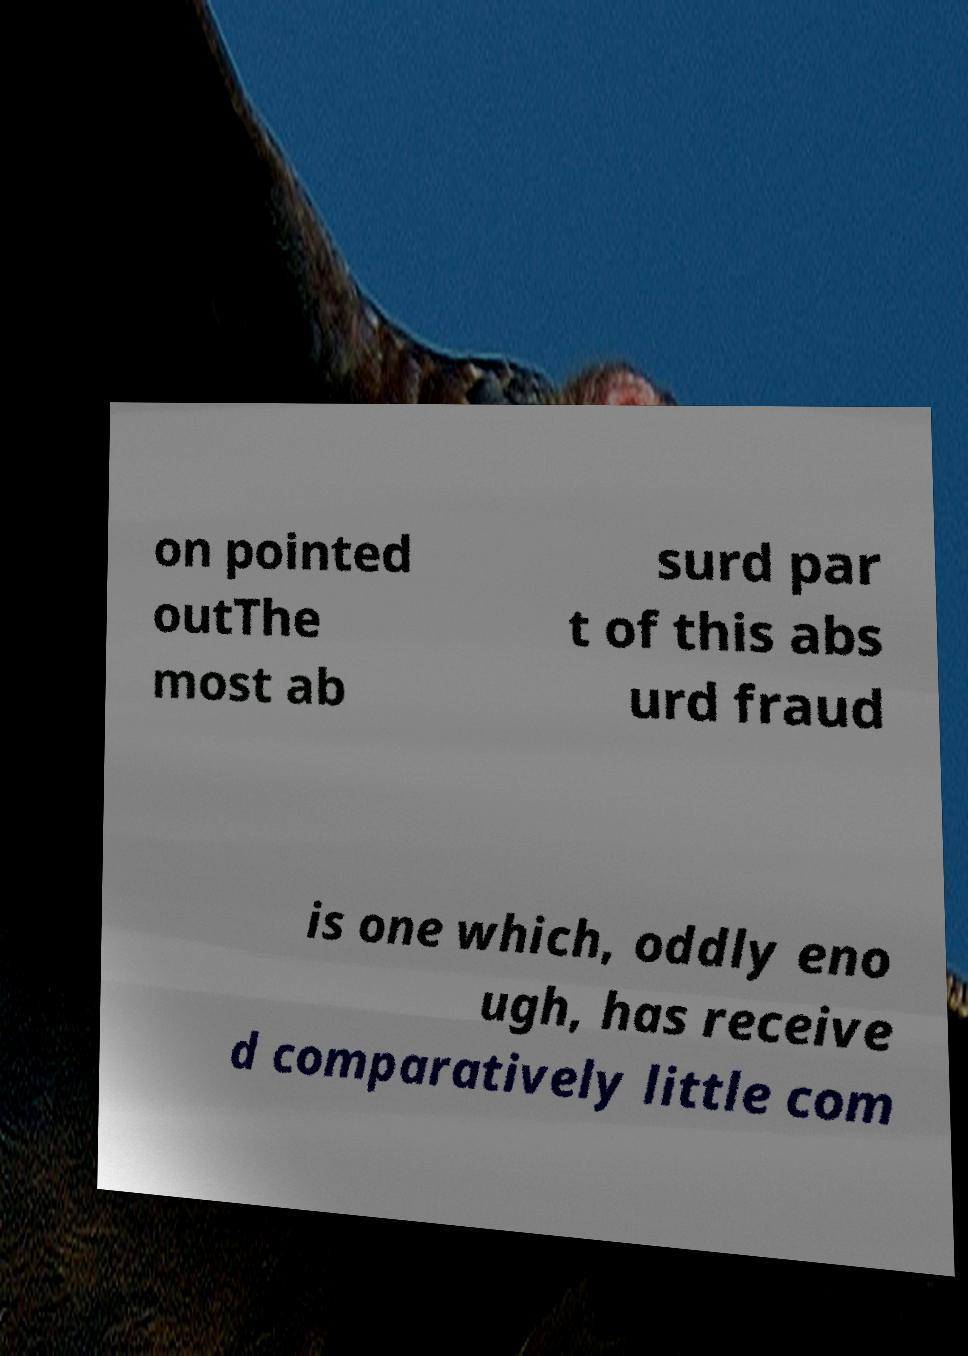Can you read and provide the text displayed in the image?This photo seems to have some interesting text. Can you extract and type it out for me? on pointed outThe most ab surd par t of this abs urd fraud is one which, oddly eno ugh, has receive d comparatively little com 